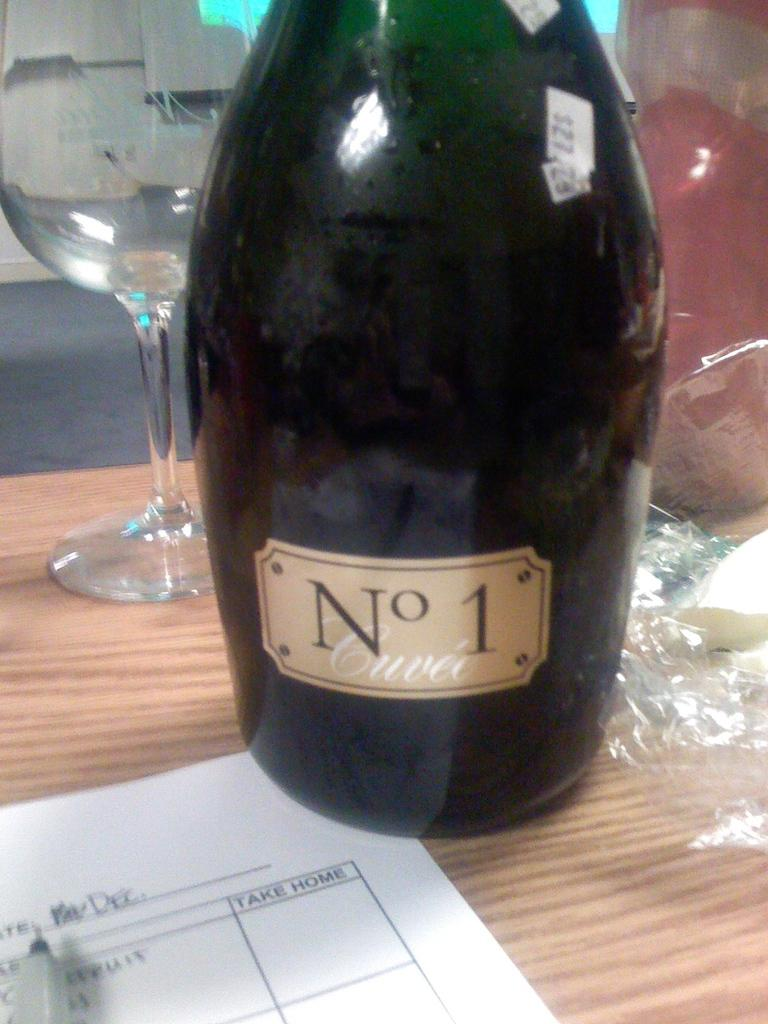<image>
Summarize the visual content of the image. A bottle says "No 1" on the front label. 